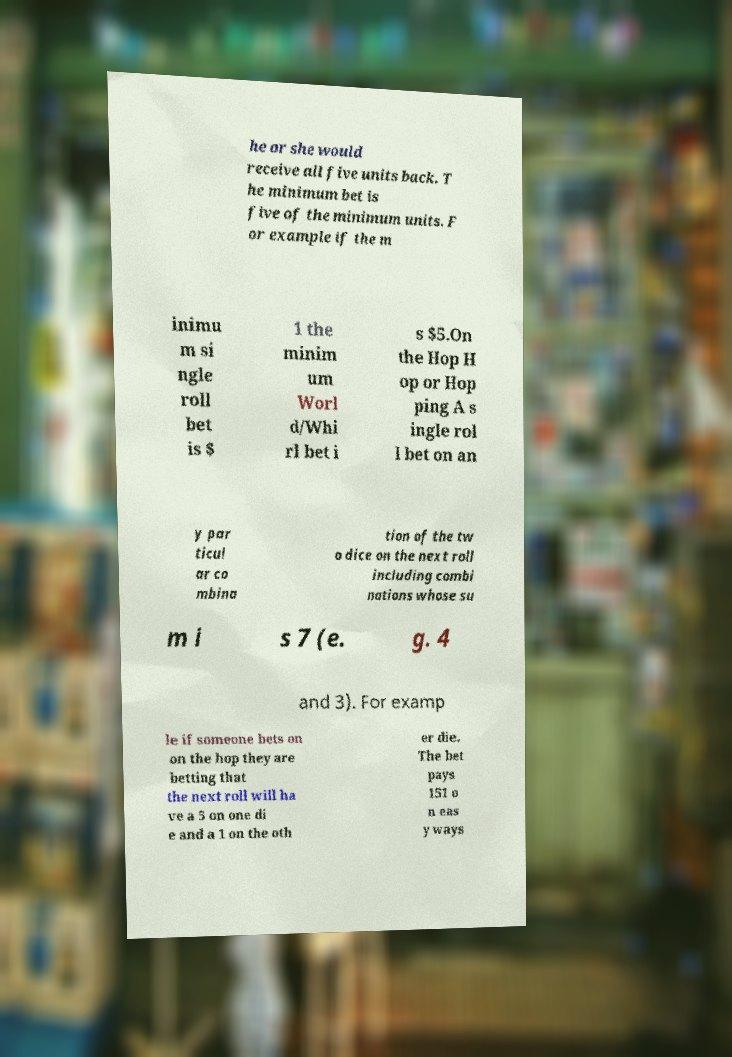There's text embedded in this image that I need extracted. Can you transcribe it verbatim? he or she would receive all five units back. T he minimum bet is five of the minimum units. F or example if the m inimu m si ngle roll bet is $ 1 the minim um Worl d/Whi rl bet i s $5.On the Hop H op or Hop ping A s ingle rol l bet on an y par ticul ar co mbina tion of the tw o dice on the next roll including combi nations whose su m i s 7 (e. g. 4 and 3). For examp le if someone bets on on the hop they are betting that the next roll will ha ve a 5 on one di e and a 1 on the oth er die. The bet pays 151 o n eas y ways 